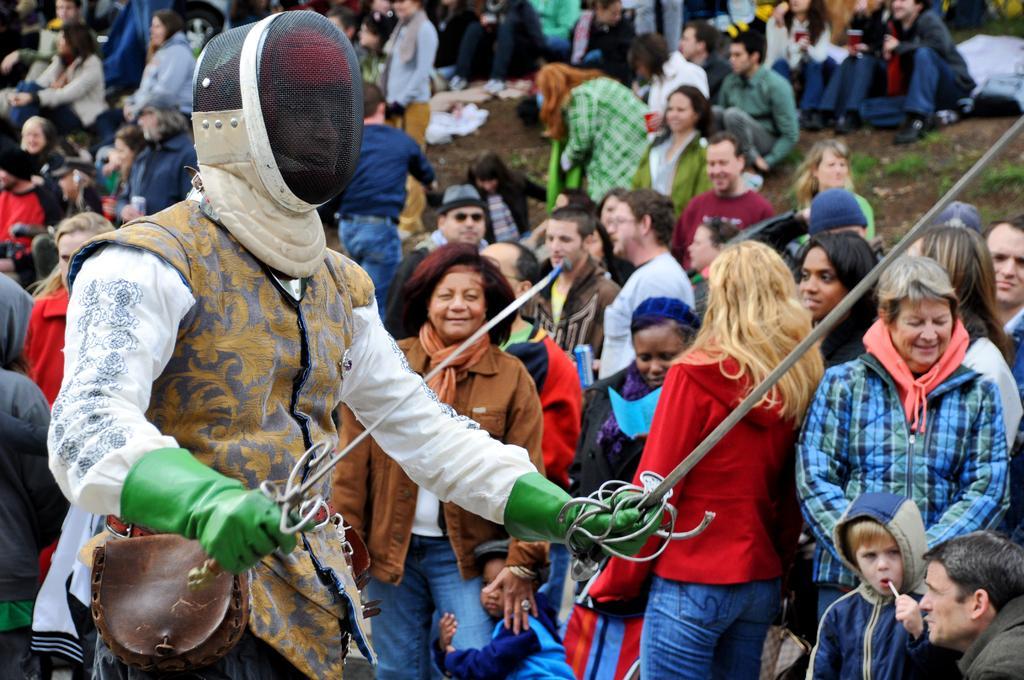Please provide a concise description of this image. In this image we can see people. Front this person wore a helmet and holding weapons. 